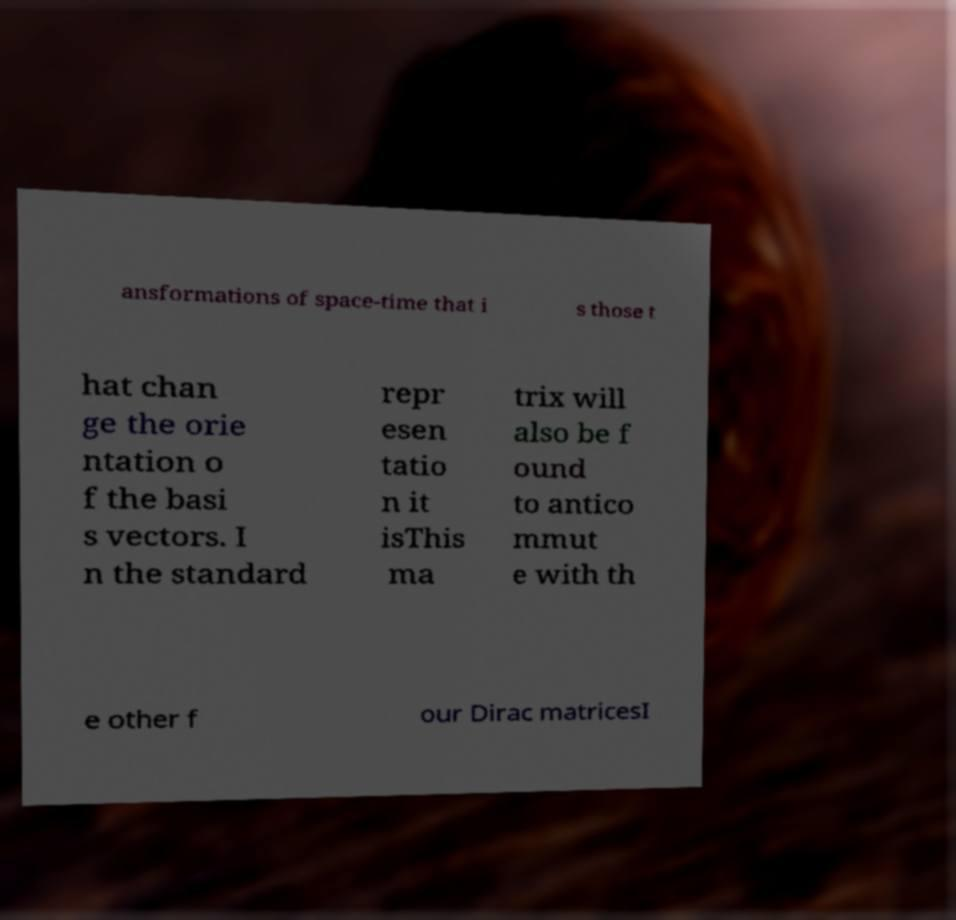Please identify and transcribe the text found in this image. ansformations of space-time that i s those t hat chan ge the orie ntation o f the basi s vectors. I n the standard repr esen tatio n it isThis ma trix will also be f ound to antico mmut e with th e other f our Dirac matricesI 